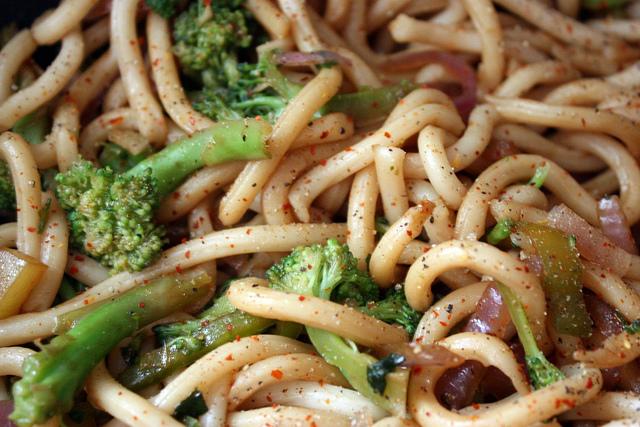Are these worms?
Answer briefly. No. Are there pieces of broccoli in this food?
Write a very short answer. Yes. Does this meal appear to be bland or well spiced?
Quick response, please. Well spiced. 